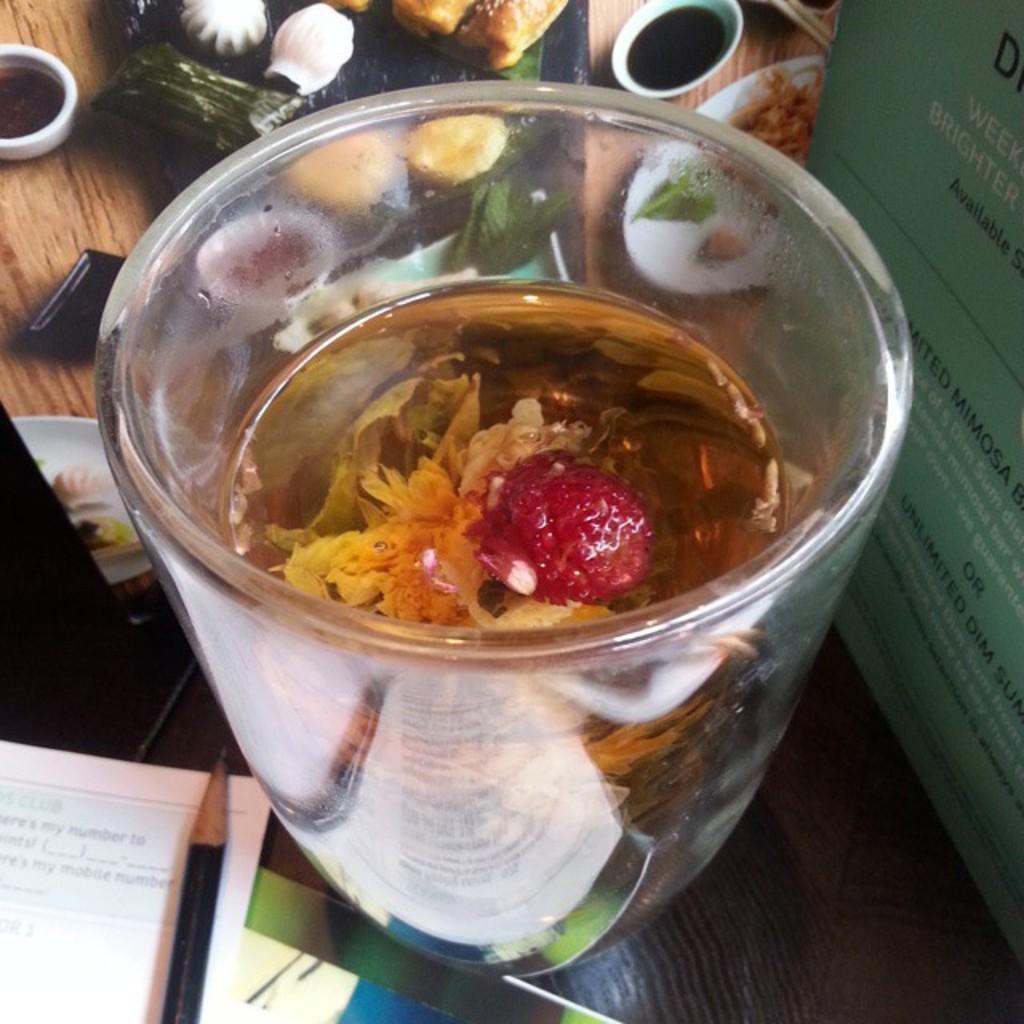Could you give a brief overview of what you see in this image? In this picture I can see the brown color surface on which there is a pencil, a paper, a cup in which there is liquid and I see yellow and red color thing. On the right side of this picture I can see a green color thing on which there are words written. In the background I can see different types of food items. 